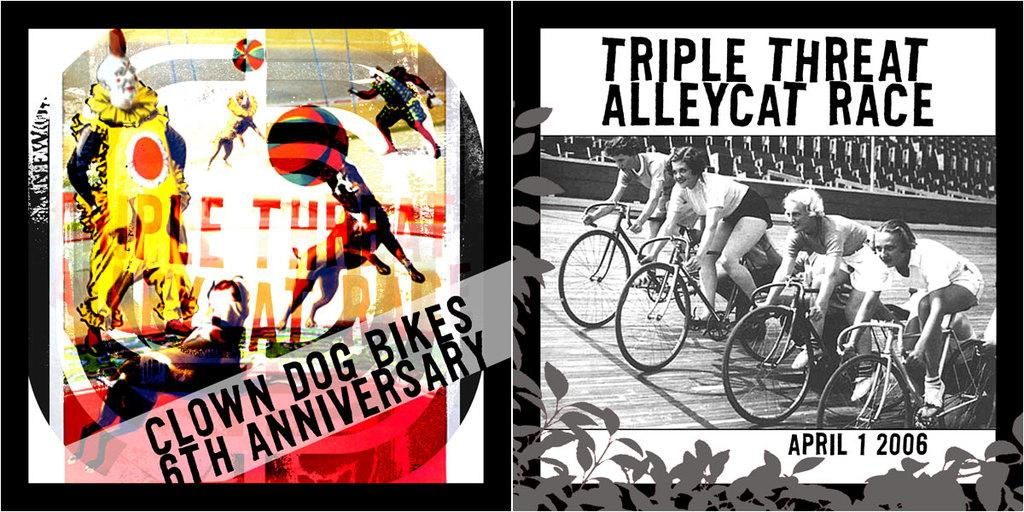<image>
Summarize the visual content of the image. Clown Dog Bikes participated in the Triple Threat Alleycat Race in April 2006. 